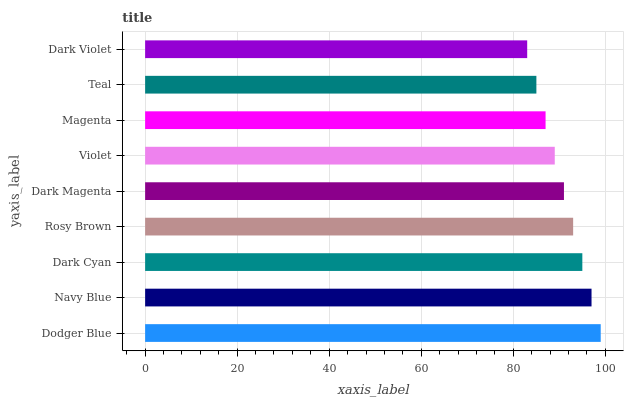Is Dark Violet the minimum?
Answer yes or no. Yes. Is Dodger Blue the maximum?
Answer yes or no. Yes. Is Navy Blue the minimum?
Answer yes or no. No. Is Navy Blue the maximum?
Answer yes or no. No. Is Dodger Blue greater than Navy Blue?
Answer yes or no. Yes. Is Navy Blue less than Dodger Blue?
Answer yes or no. Yes. Is Navy Blue greater than Dodger Blue?
Answer yes or no. No. Is Dodger Blue less than Navy Blue?
Answer yes or no. No. Is Dark Magenta the high median?
Answer yes or no. Yes. Is Dark Magenta the low median?
Answer yes or no. Yes. Is Rosy Brown the high median?
Answer yes or no. No. Is Dark Violet the low median?
Answer yes or no. No. 